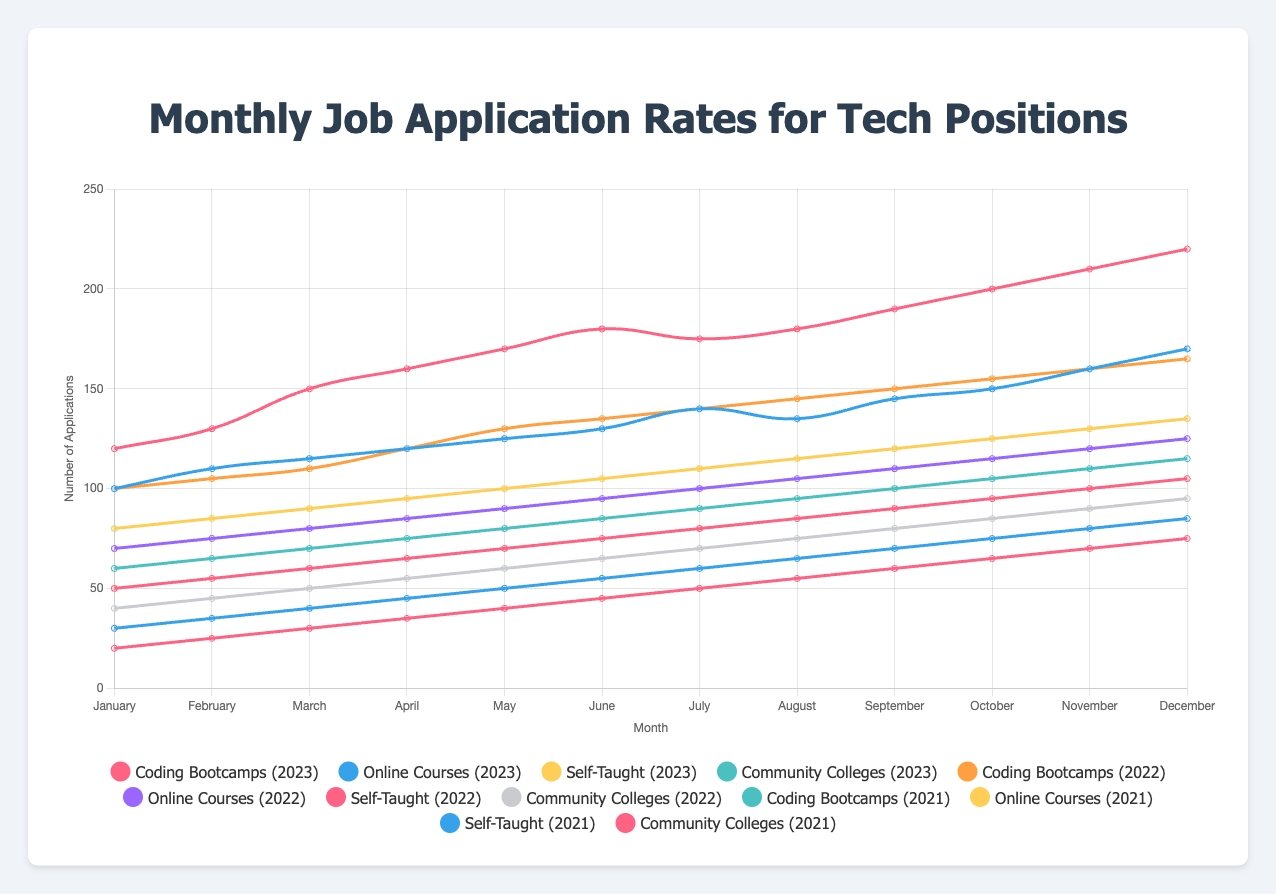Which program had the highest number of applications in December 2023? To identify which program had the highest applications in December 2023, look at the figure for December 2023 and compare the values for each program. Coding Bootcamps had 220 applications, Online Courses had 170, Self-Taught had 135, and Community Colleges had 115. The highest number is for Coding Bootcamps.
Answer: Coding Bootcamps How did the number of applications from Coding Bootcamps change from January 2023 to December 2023? To see the change in number of applications for Coding Bootcamps, look at the figures for January 2023 (120 applications) and December 2023 (220 applications). Subtract the January number from the December number: 220 - 120 = 100.
Answer: Increased by 100 applications Which program saw the highest rate of increase in applications from 2021 to 2023? To find the program with the highest rate of increase, compare the rates for each program across the three years. Coding Bootcamps increased from 80 to 220 applications (140 applications), Online Courses increased from 50 to 170 applications (120 applications), Self-Taught increased from 30 to 135 applications (105 applications), and Community Colleges increased from 20 to 115 applications (95 applications). The highest increase is for Coding Bootcamps with an increase of 140 applications.
Answer: Coding Bootcamps In November 2022, how did the number of applications for Online Courses compare with Self-Taught? Look at the figure for November 2022 and compare the values for Online Courses (120 applications) and Self-Taught (100 applications). Online Courses had more applications in November 2022.
Answer: Online Courses had more applications What was the average number of applications for Community Colleges in 2021? To find the average number of applications, sum up the monthly applications for Community Colleges in 2021 and divide by 12: (20 + 25 + 30 + 35 + 40 + 45 + 50 + 55 + 60 + 65 + 70 + 75) = 570. Then divide by 12: 570 / 12 = 47.5.
Answer: 47.5 Which year saw the greatest increase in applications for Self-Taught programs from January to December? Compare the increase in applications from January to December for each year for Self-Taught programs: 2021 (30 to 85, an increase of 55), 2022 (50 to 105, an increase of 55), and 2023 (80 to 135, an increase of 55). All three years saw an equal increase of 55 applications.
Answer: The increase was equal in all three years What is the trend in application rates for Online Courses from January to December 2023? The trend can be observed by noting the change in application rates at various points: from January (100) to December (170), we see an overall increasing trend in application rates.
Answer: Increasing trend Compare the number of applications from Coding Bootcamps and Community Colleges in July 2023. Look at the figure for July 2023 and compare the number of applications from Coding Bootcamps (175) and Community Colleges (90). Coding Bootcamps had more applications.
Answer: Coding Bootcamps had more applications What was the total number of applications for Coding Bootcamps in 2022? To find the total number of applications, sum the monthly applications for Coding Bootcamps in 2022: 100 + 105 + 110 + 120 + 130 + 135 + 140 + 145 + 150 + 155 + 160 + 165 = 1615.
Answer: 1615 applications 